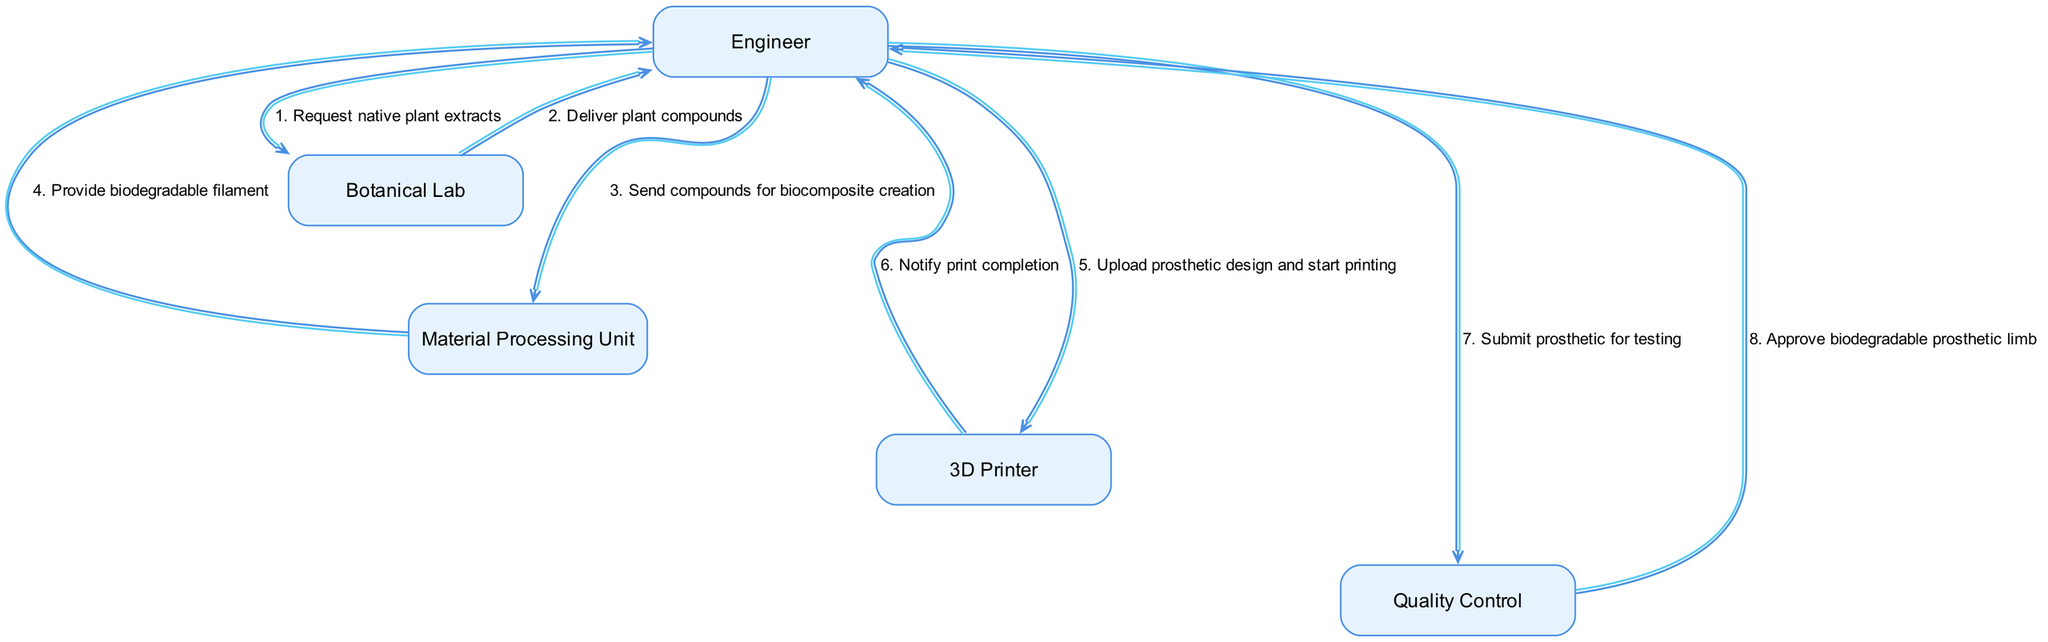What is the first action taken by the Engineer? The first action visible in the sequence diagram shows the Engineer sending a request to the Botanical Lab for native plant extracts, which is the initiating step of the process.
Answer: Request native plant extracts How many actors are involved in the manufacturing process? The diagram lists five distinct actors: Engineer, Botanical Lab, Material Processing Unit, 3D Printer, and Quality Control, indicating the number of participants in the process.
Answer: Five What does the Quality Control approve at the end of the process? Near the end of the sequence, the Quality Control interacts with the Engineer to indicate approval for the biodegradable prosthetic limb, showing the conclusion of the process.
Answer: Biodegradable prosthetic limb What action follows the Material Processing Unit providing biodegradable filament? After the Material Processing Unit provides the biodegradable filament to the Engineer, the next action taken by the Engineer is to upload the prosthetic design and start printing, which indicates the continuation of the process flow.
Answer: Upload prosthetic design and start printing Which actor notifies the Engineer of print completion? The 3D Printer is responsible for notifying the Engineer once the printing of the prosthetic limb is completed, displaying a critical step in the manufacturing workflow.
Answer: 3D Printer 